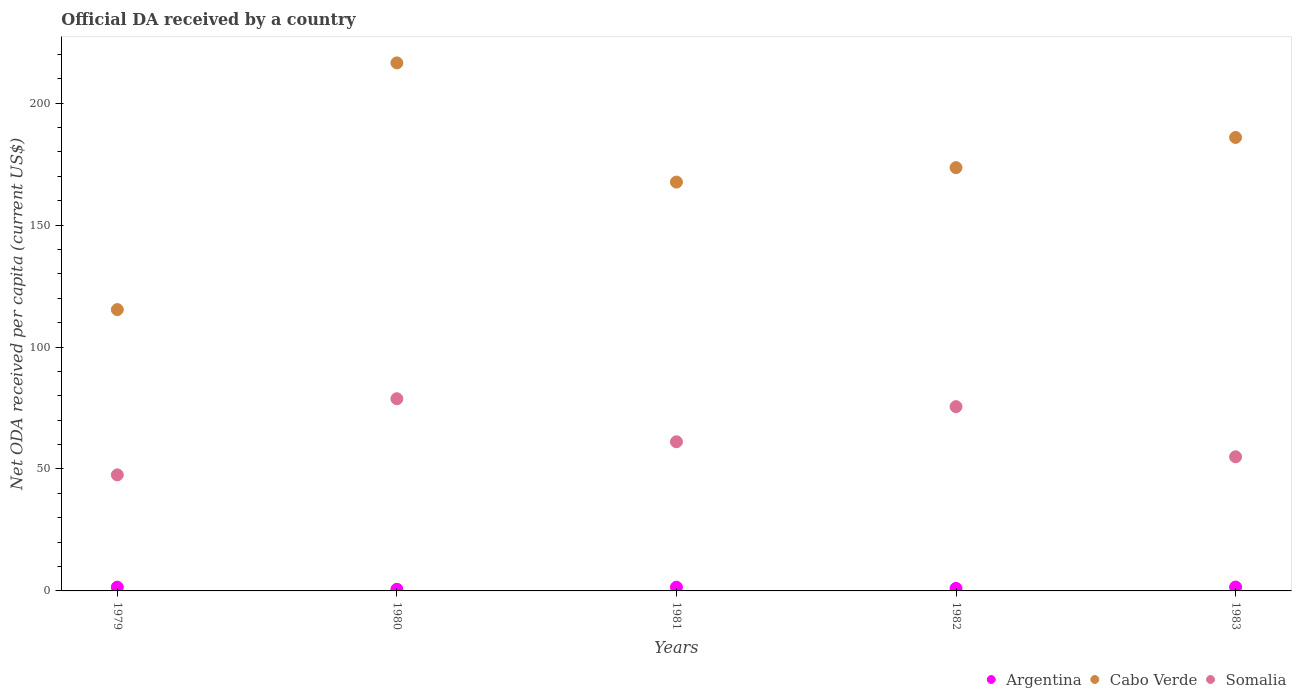Is the number of dotlines equal to the number of legend labels?
Offer a very short reply. Yes. What is the ODA received in in Somalia in 1980?
Offer a terse response. 78.81. Across all years, what is the maximum ODA received in in Somalia?
Provide a short and direct response. 78.81. Across all years, what is the minimum ODA received in in Somalia?
Keep it short and to the point. 47.59. In which year was the ODA received in in Somalia minimum?
Your answer should be very brief. 1979. What is the total ODA received in in Cabo Verde in the graph?
Your response must be concise. 859.06. What is the difference between the ODA received in in Argentina in 1979 and that in 1983?
Provide a short and direct response. -0.04. What is the difference between the ODA received in in Cabo Verde in 1983 and the ODA received in in Argentina in 1982?
Make the answer very short. 184.93. What is the average ODA received in in Cabo Verde per year?
Provide a short and direct response. 171.81. In the year 1981, what is the difference between the ODA received in in Argentina and ODA received in in Somalia?
Offer a very short reply. -59.64. In how many years, is the ODA received in in Argentina greater than 100 US$?
Ensure brevity in your answer.  0. What is the ratio of the ODA received in in Cabo Verde in 1979 to that in 1981?
Provide a short and direct response. 0.69. Is the ODA received in in Argentina in 1979 less than that in 1983?
Your response must be concise. Yes. Is the difference between the ODA received in in Argentina in 1979 and 1981 greater than the difference between the ODA received in in Somalia in 1979 and 1981?
Provide a succinct answer. Yes. What is the difference between the highest and the second highest ODA received in in Somalia?
Offer a terse response. 3.25. What is the difference between the highest and the lowest ODA received in in Somalia?
Your answer should be compact. 31.22. Is the sum of the ODA received in in Cabo Verde in 1979 and 1983 greater than the maximum ODA received in in Argentina across all years?
Keep it short and to the point. Yes. Is it the case that in every year, the sum of the ODA received in in Somalia and ODA received in in Argentina  is greater than the ODA received in in Cabo Verde?
Make the answer very short. No. Is the ODA received in in Argentina strictly greater than the ODA received in in Somalia over the years?
Give a very brief answer. No. Is the ODA received in in Cabo Verde strictly less than the ODA received in in Argentina over the years?
Your answer should be compact. No. What is the difference between two consecutive major ticks on the Y-axis?
Keep it short and to the point. 50. Does the graph contain grids?
Provide a short and direct response. No. Where does the legend appear in the graph?
Ensure brevity in your answer.  Bottom right. How many legend labels are there?
Keep it short and to the point. 3. What is the title of the graph?
Keep it short and to the point. Official DA received by a country. What is the label or title of the Y-axis?
Give a very brief answer. Net ODA received per capita (current US$). What is the Net ODA received per capita (current US$) of Argentina in 1979?
Ensure brevity in your answer.  1.55. What is the Net ODA received per capita (current US$) in Cabo Verde in 1979?
Ensure brevity in your answer.  115.36. What is the Net ODA received per capita (current US$) in Somalia in 1979?
Provide a short and direct response. 47.59. What is the Net ODA received per capita (current US$) of Argentina in 1980?
Make the answer very short. 0.69. What is the Net ODA received per capita (current US$) in Cabo Verde in 1980?
Ensure brevity in your answer.  216.53. What is the Net ODA received per capita (current US$) in Somalia in 1980?
Provide a short and direct response. 78.81. What is the Net ODA received per capita (current US$) of Argentina in 1981?
Keep it short and to the point. 1.53. What is the Net ODA received per capita (current US$) in Cabo Verde in 1981?
Ensure brevity in your answer.  167.65. What is the Net ODA received per capita (current US$) in Somalia in 1981?
Ensure brevity in your answer.  61.16. What is the Net ODA received per capita (current US$) of Argentina in 1982?
Make the answer very short. 1.03. What is the Net ODA received per capita (current US$) of Cabo Verde in 1982?
Your answer should be very brief. 173.57. What is the Net ODA received per capita (current US$) in Somalia in 1982?
Give a very brief answer. 75.56. What is the Net ODA received per capita (current US$) of Argentina in 1983?
Keep it short and to the point. 1.6. What is the Net ODA received per capita (current US$) in Cabo Verde in 1983?
Ensure brevity in your answer.  185.95. What is the Net ODA received per capita (current US$) in Somalia in 1983?
Offer a terse response. 55.01. Across all years, what is the maximum Net ODA received per capita (current US$) of Argentina?
Offer a terse response. 1.6. Across all years, what is the maximum Net ODA received per capita (current US$) in Cabo Verde?
Your answer should be compact. 216.53. Across all years, what is the maximum Net ODA received per capita (current US$) in Somalia?
Ensure brevity in your answer.  78.81. Across all years, what is the minimum Net ODA received per capita (current US$) of Argentina?
Offer a terse response. 0.69. Across all years, what is the minimum Net ODA received per capita (current US$) in Cabo Verde?
Ensure brevity in your answer.  115.36. Across all years, what is the minimum Net ODA received per capita (current US$) in Somalia?
Ensure brevity in your answer.  47.59. What is the total Net ODA received per capita (current US$) of Argentina in the graph?
Your answer should be very brief. 6.39. What is the total Net ODA received per capita (current US$) of Cabo Verde in the graph?
Your answer should be very brief. 859.06. What is the total Net ODA received per capita (current US$) in Somalia in the graph?
Give a very brief answer. 318.14. What is the difference between the Net ODA received per capita (current US$) of Argentina in 1979 and that in 1980?
Your answer should be compact. 0.86. What is the difference between the Net ODA received per capita (current US$) of Cabo Verde in 1979 and that in 1980?
Keep it short and to the point. -101.17. What is the difference between the Net ODA received per capita (current US$) of Somalia in 1979 and that in 1980?
Offer a terse response. -31.22. What is the difference between the Net ODA received per capita (current US$) in Argentina in 1979 and that in 1981?
Keep it short and to the point. 0.03. What is the difference between the Net ODA received per capita (current US$) in Cabo Verde in 1979 and that in 1981?
Provide a succinct answer. -52.29. What is the difference between the Net ODA received per capita (current US$) of Somalia in 1979 and that in 1981?
Offer a terse response. -13.57. What is the difference between the Net ODA received per capita (current US$) of Argentina in 1979 and that in 1982?
Your answer should be very brief. 0.53. What is the difference between the Net ODA received per capita (current US$) in Cabo Verde in 1979 and that in 1982?
Provide a short and direct response. -58.21. What is the difference between the Net ODA received per capita (current US$) of Somalia in 1979 and that in 1982?
Provide a succinct answer. -27.97. What is the difference between the Net ODA received per capita (current US$) of Argentina in 1979 and that in 1983?
Your response must be concise. -0.04. What is the difference between the Net ODA received per capita (current US$) in Cabo Verde in 1979 and that in 1983?
Your answer should be compact. -70.59. What is the difference between the Net ODA received per capita (current US$) in Somalia in 1979 and that in 1983?
Offer a very short reply. -7.41. What is the difference between the Net ODA received per capita (current US$) in Argentina in 1980 and that in 1981?
Provide a short and direct response. -0.83. What is the difference between the Net ODA received per capita (current US$) of Cabo Verde in 1980 and that in 1981?
Offer a very short reply. 48.88. What is the difference between the Net ODA received per capita (current US$) in Somalia in 1980 and that in 1981?
Give a very brief answer. 17.65. What is the difference between the Net ODA received per capita (current US$) in Argentina in 1980 and that in 1982?
Your response must be concise. -0.33. What is the difference between the Net ODA received per capita (current US$) of Cabo Verde in 1980 and that in 1982?
Give a very brief answer. 42.95. What is the difference between the Net ODA received per capita (current US$) of Somalia in 1980 and that in 1982?
Your answer should be compact. 3.25. What is the difference between the Net ODA received per capita (current US$) of Argentina in 1980 and that in 1983?
Make the answer very short. -0.9. What is the difference between the Net ODA received per capita (current US$) in Cabo Verde in 1980 and that in 1983?
Your answer should be very brief. 30.57. What is the difference between the Net ODA received per capita (current US$) in Somalia in 1980 and that in 1983?
Offer a very short reply. 23.81. What is the difference between the Net ODA received per capita (current US$) of Argentina in 1981 and that in 1982?
Give a very brief answer. 0.5. What is the difference between the Net ODA received per capita (current US$) of Cabo Verde in 1981 and that in 1982?
Make the answer very short. -5.92. What is the difference between the Net ODA received per capita (current US$) of Somalia in 1981 and that in 1982?
Your answer should be compact. -14.4. What is the difference between the Net ODA received per capita (current US$) of Argentina in 1981 and that in 1983?
Your answer should be very brief. -0.07. What is the difference between the Net ODA received per capita (current US$) in Cabo Verde in 1981 and that in 1983?
Offer a terse response. -18.3. What is the difference between the Net ODA received per capita (current US$) in Somalia in 1981 and that in 1983?
Offer a very short reply. 6.16. What is the difference between the Net ODA received per capita (current US$) of Argentina in 1982 and that in 1983?
Your answer should be compact. -0.57. What is the difference between the Net ODA received per capita (current US$) of Cabo Verde in 1982 and that in 1983?
Give a very brief answer. -12.38. What is the difference between the Net ODA received per capita (current US$) in Somalia in 1982 and that in 1983?
Your answer should be compact. 20.55. What is the difference between the Net ODA received per capita (current US$) in Argentina in 1979 and the Net ODA received per capita (current US$) in Cabo Verde in 1980?
Offer a very short reply. -214.97. What is the difference between the Net ODA received per capita (current US$) in Argentina in 1979 and the Net ODA received per capita (current US$) in Somalia in 1980?
Keep it short and to the point. -77.26. What is the difference between the Net ODA received per capita (current US$) of Cabo Verde in 1979 and the Net ODA received per capita (current US$) of Somalia in 1980?
Provide a succinct answer. 36.54. What is the difference between the Net ODA received per capita (current US$) in Argentina in 1979 and the Net ODA received per capita (current US$) in Cabo Verde in 1981?
Your answer should be compact. -166.1. What is the difference between the Net ODA received per capita (current US$) in Argentina in 1979 and the Net ODA received per capita (current US$) in Somalia in 1981?
Your answer should be compact. -59.61. What is the difference between the Net ODA received per capita (current US$) in Cabo Verde in 1979 and the Net ODA received per capita (current US$) in Somalia in 1981?
Give a very brief answer. 54.2. What is the difference between the Net ODA received per capita (current US$) in Argentina in 1979 and the Net ODA received per capita (current US$) in Cabo Verde in 1982?
Offer a very short reply. -172.02. What is the difference between the Net ODA received per capita (current US$) in Argentina in 1979 and the Net ODA received per capita (current US$) in Somalia in 1982?
Your answer should be very brief. -74.01. What is the difference between the Net ODA received per capita (current US$) in Cabo Verde in 1979 and the Net ODA received per capita (current US$) in Somalia in 1982?
Give a very brief answer. 39.8. What is the difference between the Net ODA received per capita (current US$) in Argentina in 1979 and the Net ODA received per capita (current US$) in Cabo Verde in 1983?
Offer a terse response. -184.4. What is the difference between the Net ODA received per capita (current US$) in Argentina in 1979 and the Net ODA received per capita (current US$) in Somalia in 1983?
Your answer should be compact. -53.46. What is the difference between the Net ODA received per capita (current US$) in Cabo Verde in 1979 and the Net ODA received per capita (current US$) in Somalia in 1983?
Your answer should be compact. 60.35. What is the difference between the Net ODA received per capita (current US$) in Argentina in 1980 and the Net ODA received per capita (current US$) in Cabo Verde in 1981?
Provide a short and direct response. -166.96. What is the difference between the Net ODA received per capita (current US$) in Argentina in 1980 and the Net ODA received per capita (current US$) in Somalia in 1981?
Provide a succinct answer. -60.47. What is the difference between the Net ODA received per capita (current US$) of Cabo Verde in 1980 and the Net ODA received per capita (current US$) of Somalia in 1981?
Offer a terse response. 155.36. What is the difference between the Net ODA received per capita (current US$) in Argentina in 1980 and the Net ODA received per capita (current US$) in Cabo Verde in 1982?
Keep it short and to the point. -172.88. What is the difference between the Net ODA received per capita (current US$) of Argentina in 1980 and the Net ODA received per capita (current US$) of Somalia in 1982?
Your answer should be very brief. -74.87. What is the difference between the Net ODA received per capita (current US$) in Cabo Verde in 1980 and the Net ODA received per capita (current US$) in Somalia in 1982?
Your response must be concise. 140.97. What is the difference between the Net ODA received per capita (current US$) of Argentina in 1980 and the Net ODA received per capita (current US$) of Cabo Verde in 1983?
Make the answer very short. -185.26. What is the difference between the Net ODA received per capita (current US$) of Argentina in 1980 and the Net ODA received per capita (current US$) of Somalia in 1983?
Provide a succinct answer. -54.31. What is the difference between the Net ODA received per capita (current US$) in Cabo Verde in 1980 and the Net ODA received per capita (current US$) in Somalia in 1983?
Ensure brevity in your answer.  161.52. What is the difference between the Net ODA received per capita (current US$) in Argentina in 1981 and the Net ODA received per capita (current US$) in Cabo Verde in 1982?
Offer a terse response. -172.05. What is the difference between the Net ODA received per capita (current US$) of Argentina in 1981 and the Net ODA received per capita (current US$) of Somalia in 1982?
Give a very brief answer. -74.03. What is the difference between the Net ODA received per capita (current US$) of Cabo Verde in 1981 and the Net ODA received per capita (current US$) of Somalia in 1982?
Your answer should be compact. 92.09. What is the difference between the Net ODA received per capita (current US$) in Argentina in 1981 and the Net ODA received per capita (current US$) in Cabo Verde in 1983?
Offer a very short reply. -184.43. What is the difference between the Net ODA received per capita (current US$) of Argentina in 1981 and the Net ODA received per capita (current US$) of Somalia in 1983?
Offer a very short reply. -53.48. What is the difference between the Net ODA received per capita (current US$) of Cabo Verde in 1981 and the Net ODA received per capita (current US$) of Somalia in 1983?
Provide a short and direct response. 112.64. What is the difference between the Net ODA received per capita (current US$) in Argentina in 1982 and the Net ODA received per capita (current US$) in Cabo Verde in 1983?
Make the answer very short. -184.93. What is the difference between the Net ODA received per capita (current US$) of Argentina in 1982 and the Net ODA received per capita (current US$) of Somalia in 1983?
Your answer should be very brief. -53.98. What is the difference between the Net ODA received per capita (current US$) of Cabo Verde in 1982 and the Net ODA received per capita (current US$) of Somalia in 1983?
Provide a short and direct response. 118.57. What is the average Net ODA received per capita (current US$) in Argentina per year?
Offer a terse response. 1.28. What is the average Net ODA received per capita (current US$) of Cabo Verde per year?
Ensure brevity in your answer.  171.81. What is the average Net ODA received per capita (current US$) in Somalia per year?
Keep it short and to the point. 63.63. In the year 1979, what is the difference between the Net ODA received per capita (current US$) of Argentina and Net ODA received per capita (current US$) of Cabo Verde?
Provide a succinct answer. -113.81. In the year 1979, what is the difference between the Net ODA received per capita (current US$) of Argentina and Net ODA received per capita (current US$) of Somalia?
Your answer should be compact. -46.04. In the year 1979, what is the difference between the Net ODA received per capita (current US$) of Cabo Verde and Net ODA received per capita (current US$) of Somalia?
Ensure brevity in your answer.  67.77. In the year 1980, what is the difference between the Net ODA received per capita (current US$) of Argentina and Net ODA received per capita (current US$) of Cabo Verde?
Provide a succinct answer. -215.83. In the year 1980, what is the difference between the Net ODA received per capita (current US$) of Argentina and Net ODA received per capita (current US$) of Somalia?
Keep it short and to the point. -78.12. In the year 1980, what is the difference between the Net ODA received per capita (current US$) in Cabo Verde and Net ODA received per capita (current US$) in Somalia?
Your answer should be compact. 137.71. In the year 1981, what is the difference between the Net ODA received per capita (current US$) in Argentina and Net ODA received per capita (current US$) in Cabo Verde?
Make the answer very short. -166.12. In the year 1981, what is the difference between the Net ODA received per capita (current US$) of Argentina and Net ODA received per capita (current US$) of Somalia?
Your answer should be compact. -59.64. In the year 1981, what is the difference between the Net ODA received per capita (current US$) of Cabo Verde and Net ODA received per capita (current US$) of Somalia?
Provide a short and direct response. 106.49. In the year 1982, what is the difference between the Net ODA received per capita (current US$) of Argentina and Net ODA received per capita (current US$) of Cabo Verde?
Your answer should be compact. -172.55. In the year 1982, what is the difference between the Net ODA received per capita (current US$) of Argentina and Net ODA received per capita (current US$) of Somalia?
Provide a succinct answer. -74.53. In the year 1982, what is the difference between the Net ODA received per capita (current US$) of Cabo Verde and Net ODA received per capita (current US$) of Somalia?
Keep it short and to the point. 98.01. In the year 1983, what is the difference between the Net ODA received per capita (current US$) of Argentina and Net ODA received per capita (current US$) of Cabo Verde?
Your answer should be compact. -184.36. In the year 1983, what is the difference between the Net ODA received per capita (current US$) of Argentina and Net ODA received per capita (current US$) of Somalia?
Offer a terse response. -53.41. In the year 1983, what is the difference between the Net ODA received per capita (current US$) of Cabo Verde and Net ODA received per capita (current US$) of Somalia?
Offer a terse response. 130.94. What is the ratio of the Net ODA received per capita (current US$) of Argentina in 1979 to that in 1980?
Give a very brief answer. 2.24. What is the ratio of the Net ODA received per capita (current US$) of Cabo Verde in 1979 to that in 1980?
Ensure brevity in your answer.  0.53. What is the ratio of the Net ODA received per capita (current US$) in Somalia in 1979 to that in 1980?
Give a very brief answer. 0.6. What is the ratio of the Net ODA received per capita (current US$) of Argentina in 1979 to that in 1981?
Your answer should be compact. 1.02. What is the ratio of the Net ODA received per capita (current US$) in Cabo Verde in 1979 to that in 1981?
Provide a succinct answer. 0.69. What is the ratio of the Net ODA received per capita (current US$) in Somalia in 1979 to that in 1981?
Keep it short and to the point. 0.78. What is the ratio of the Net ODA received per capita (current US$) of Argentina in 1979 to that in 1982?
Offer a terse response. 1.51. What is the ratio of the Net ODA received per capita (current US$) of Cabo Verde in 1979 to that in 1982?
Offer a terse response. 0.66. What is the ratio of the Net ODA received per capita (current US$) of Somalia in 1979 to that in 1982?
Your response must be concise. 0.63. What is the ratio of the Net ODA received per capita (current US$) in Argentina in 1979 to that in 1983?
Provide a succinct answer. 0.97. What is the ratio of the Net ODA received per capita (current US$) in Cabo Verde in 1979 to that in 1983?
Keep it short and to the point. 0.62. What is the ratio of the Net ODA received per capita (current US$) of Somalia in 1979 to that in 1983?
Ensure brevity in your answer.  0.87. What is the ratio of the Net ODA received per capita (current US$) of Argentina in 1980 to that in 1981?
Your answer should be compact. 0.45. What is the ratio of the Net ODA received per capita (current US$) in Cabo Verde in 1980 to that in 1981?
Make the answer very short. 1.29. What is the ratio of the Net ODA received per capita (current US$) in Somalia in 1980 to that in 1981?
Make the answer very short. 1.29. What is the ratio of the Net ODA received per capita (current US$) of Argentina in 1980 to that in 1982?
Provide a short and direct response. 0.68. What is the ratio of the Net ODA received per capita (current US$) in Cabo Verde in 1980 to that in 1982?
Ensure brevity in your answer.  1.25. What is the ratio of the Net ODA received per capita (current US$) in Somalia in 1980 to that in 1982?
Your answer should be compact. 1.04. What is the ratio of the Net ODA received per capita (current US$) in Argentina in 1980 to that in 1983?
Ensure brevity in your answer.  0.43. What is the ratio of the Net ODA received per capita (current US$) of Cabo Verde in 1980 to that in 1983?
Offer a very short reply. 1.16. What is the ratio of the Net ODA received per capita (current US$) of Somalia in 1980 to that in 1983?
Provide a succinct answer. 1.43. What is the ratio of the Net ODA received per capita (current US$) of Argentina in 1981 to that in 1982?
Provide a succinct answer. 1.49. What is the ratio of the Net ODA received per capita (current US$) of Cabo Verde in 1981 to that in 1982?
Your answer should be compact. 0.97. What is the ratio of the Net ODA received per capita (current US$) of Somalia in 1981 to that in 1982?
Your answer should be compact. 0.81. What is the ratio of the Net ODA received per capita (current US$) of Argentina in 1981 to that in 1983?
Your response must be concise. 0.96. What is the ratio of the Net ODA received per capita (current US$) of Cabo Verde in 1981 to that in 1983?
Your response must be concise. 0.9. What is the ratio of the Net ODA received per capita (current US$) in Somalia in 1981 to that in 1983?
Your response must be concise. 1.11. What is the ratio of the Net ODA received per capita (current US$) of Argentina in 1982 to that in 1983?
Ensure brevity in your answer.  0.64. What is the ratio of the Net ODA received per capita (current US$) of Cabo Verde in 1982 to that in 1983?
Your answer should be compact. 0.93. What is the ratio of the Net ODA received per capita (current US$) of Somalia in 1982 to that in 1983?
Keep it short and to the point. 1.37. What is the difference between the highest and the second highest Net ODA received per capita (current US$) in Argentina?
Provide a succinct answer. 0.04. What is the difference between the highest and the second highest Net ODA received per capita (current US$) of Cabo Verde?
Give a very brief answer. 30.57. What is the difference between the highest and the second highest Net ODA received per capita (current US$) in Somalia?
Ensure brevity in your answer.  3.25. What is the difference between the highest and the lowest Net ODA received per capita (current US$) of Argentina?
Provide a succinct answer. 0.9. What is the difference between the highest and the lowest Net ODA received per capita (current US$) in Cabo Verde?
Keep it short and to the point. 101.17. What is the difference between the highest and the lowest Net ODA received per capita (current US$) of Somalia?
Keep it short and to the point. 31.22. 